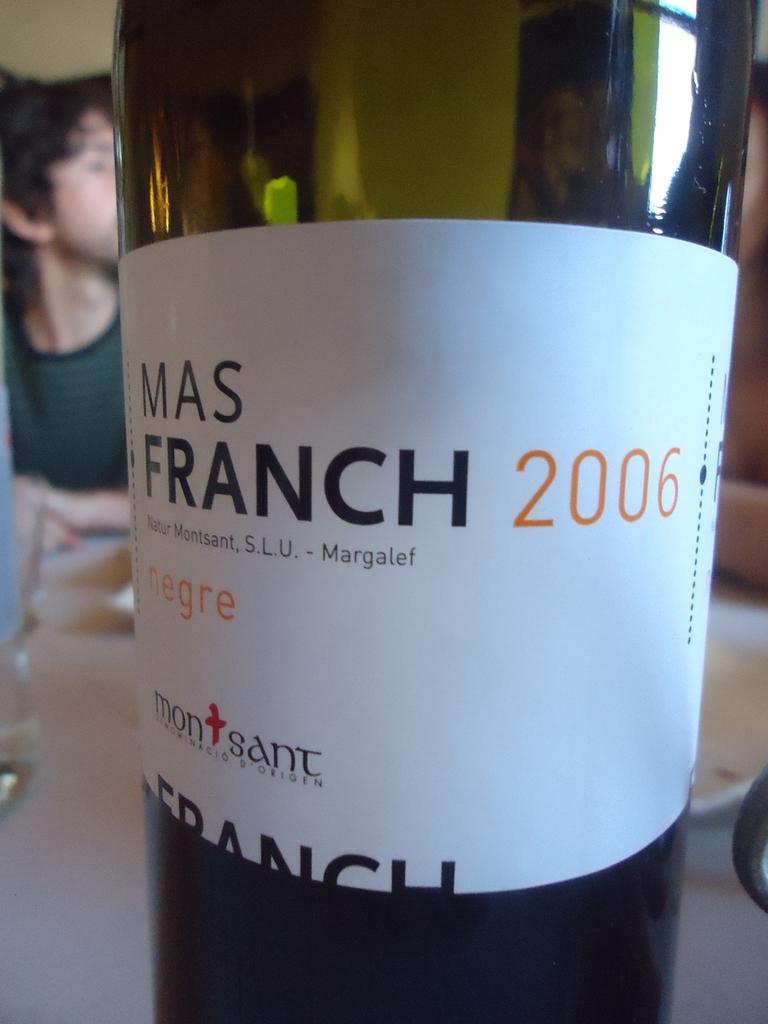What year is on this bottle of win?
Provide a succinct answer. 2006. What is the brand on this bottle?
Make the answer very short. Mas franch. 